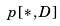<formula> <loc_0><loc_0><loc_500><loc_500>p [ * , D ]</formula> 